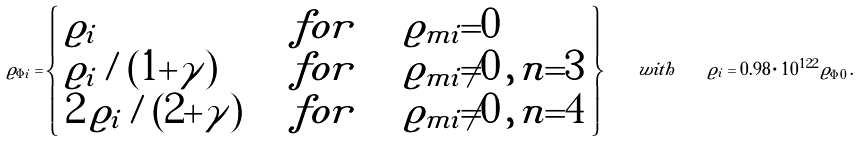Convert formula to latex. <formula><loc_0><loc_0><loc_500><loc_500>\varrho _ { \Phi i } = \left \{ \begin{array} { l l l } \varrho _ { i } \quad & f o r \quad & \varrho _ { m i } { = } 0 \\ \varrho _ { i } / ( 1 { + } \gamma ) \quad & f o r \quad & \varrho _ { m i } { \neq } 0 \, , \, n { = } 3 \\ 2 \, \varrho _ { i } / ( 2 { + } \gamma ) \quad & f o r \quad & \varrho _ { m i } { \neq } 0 \, , \, n { = } 4 \end{array} \right \} \quad w i t h \quad \varrho _ { i } = 0 . 9 8 \cdot 1 0 ^ { 1 2 2 } \, \varrho _ { \Phi 0 } \, .</formula> 